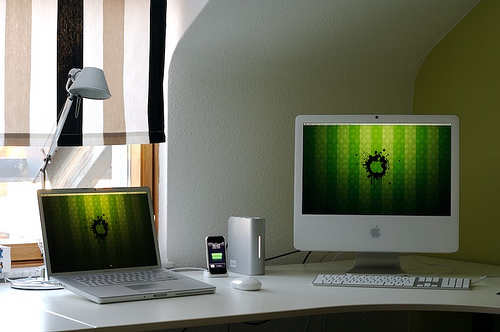<image>What is securing the laptop? It is unknown what is securing the laptop. It could be the table, a cord, the base, or the screen. What is securing the laptop? It is unknown what is securing the laptop. It can be seen that there is either a table or nothing securing the laptop. 